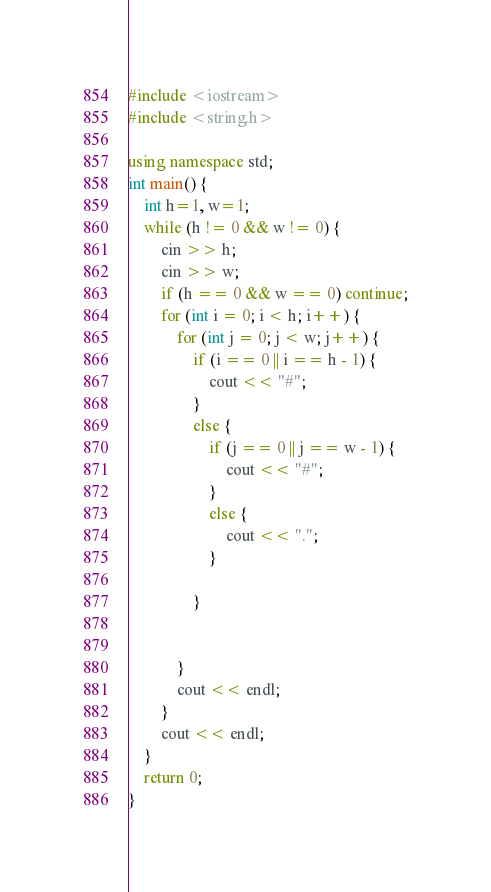Convert code to text. <code><loc_0><loc_0><loc_500><loc_500><_C++_>#include <iostream>
#include <string.h>

using namespace std;
int main() {
	int h=1, w=1;
	while (h != 0 && w != 0) {
		cin >> h;
		cin >> w;
		if (h == 0 && w == 0) continue;
		for (int i = 0; i < h; i++) {
			for (int j = 0; j < w; j++) {
				if (i == 0 || i == h - 1) {
					cout << "#";
				}
				else {
					if (j == 0 || j == w - 1) {
						cout << "#";
					}
					else {
						cout << ".";
					}
					
				}
				
				
			}
			cout << endl;
		}
		cout << endl;
	}
	return 0;
}</code> 